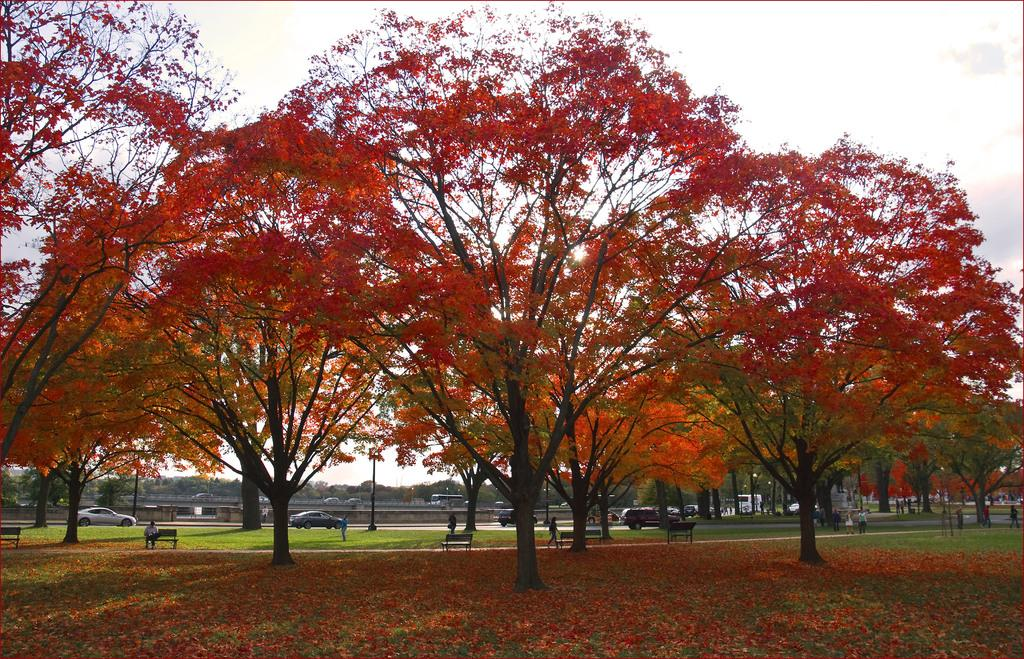What type of natural elements can be seen in the image? There are many trees in the image. What can be seen in the background of the image? There are many vehicles in the background of the image. How many people are present in the image? There are many people in the image. What type of seating is available in the image? There are benches in the image. What is visible in the sky in the background of the image? The sky is visible in the background of the image. What type of brick structure can be seen near the dock in the image? There is no dock or brick structure present in the image. How many passengers are waiting for the boat at the dock in the image? There is no dock or passengers present in the image. 